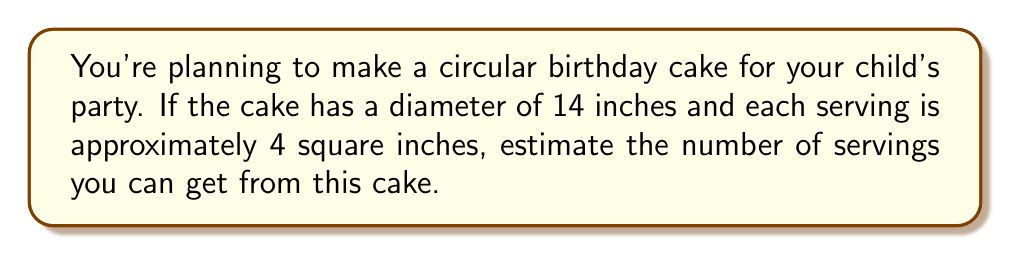Give your solution to this math problem. Let's approach this step-by-step:

1) First, we need to calculate the area of the circular cake:
   The area of a circle is given by the formula $A = \pi r^2$, where $r$ is the radius.

2) The diameter is 14 inches, so the radius is half of that:
   $r = 14 \div 2 = 7$ inches

3) Now we can calculate the area:
   $A = \pi (7^2) = 49\pi$ square inches

4) We can approximate $\pi$ as 3.14:
   $A \approx 49 \times 3.14 = 153.86$ square inches

5) Each serving is 4 square inches, so to find the number of servings, we divide the total area by the area per serving:

   Number of servings $= \frac{\text{Total Area}}{\text{Area per Serving}} = \frac{153.86}{4} \approx 38.465$

6) Since we can't have a fraction of a serving, we round down to the nearest whole number.
Answer: 38 servings 